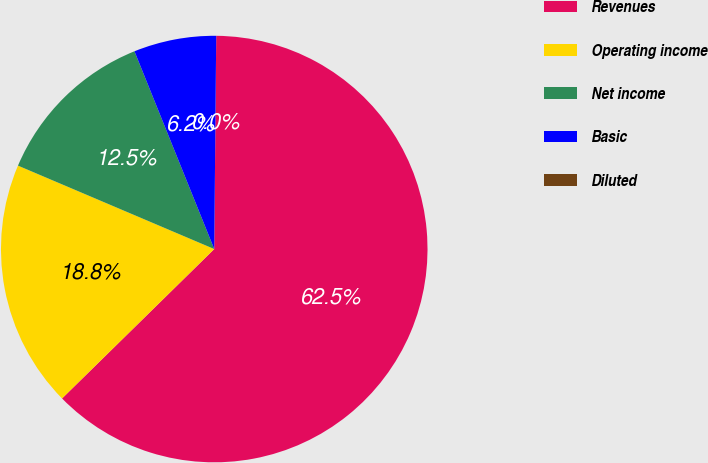Convert chart. <chart><loc_0><loc_0><loc_500><loc_500><pie_chart><fcel>Revenues<fcel>Operating income<fcel>Net income<fcel>Basic<fcel>Diluted<nl><fcel>62.5%<fcel>18.75%<fcel>12.5%<fcel>6.25%<fcel>0.0%<nl></chart> 